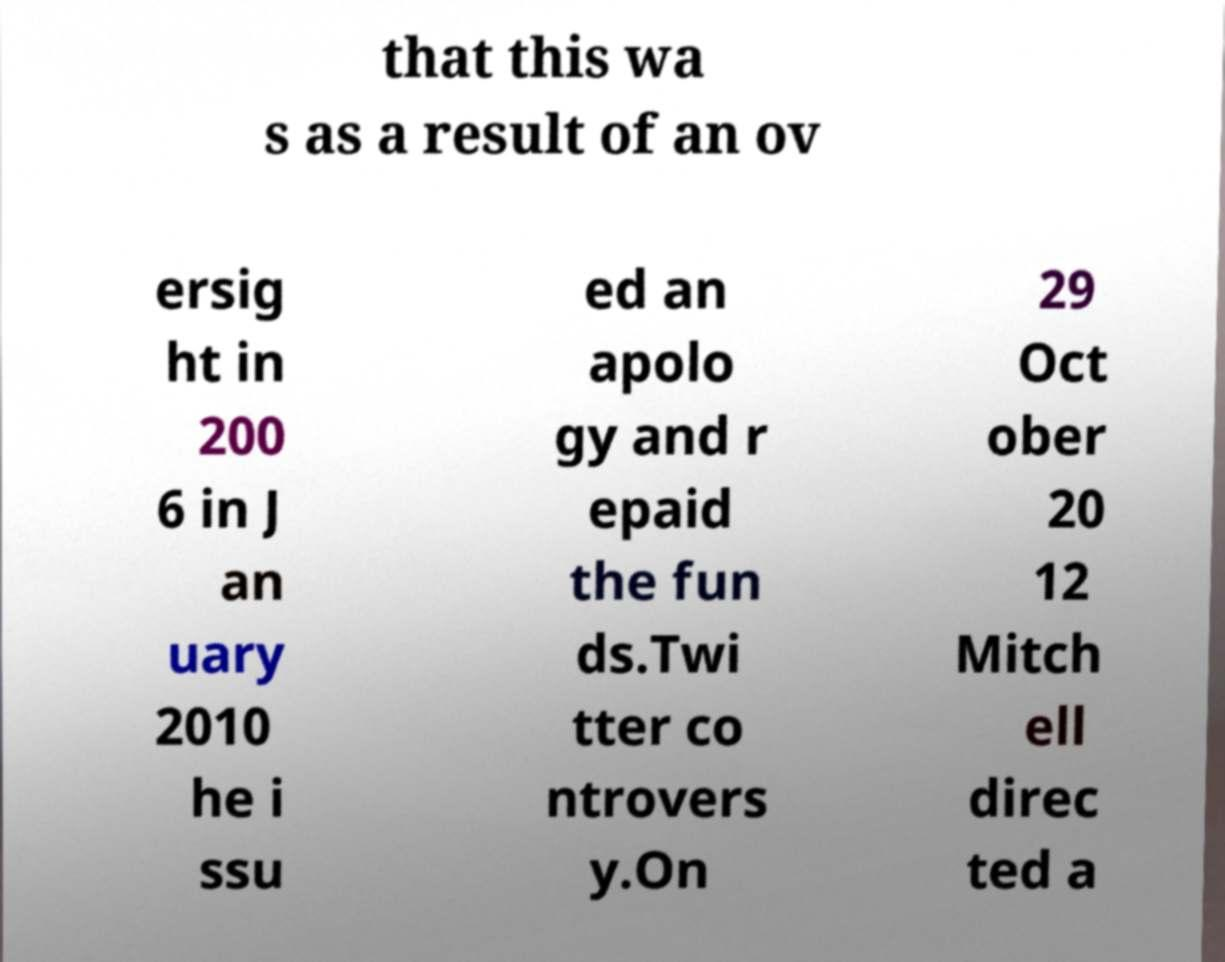Can you accurately transcribe the text from the provided image for me? that this wa s as a result of an ov ersig ht in 200 6 in J an uary 2010 he i ssu ed an apolo gy and r epaid the fun ds.Twi tter co ntrovers y.On 29 Oct ober 20 12 Mitch ell direc ted a 